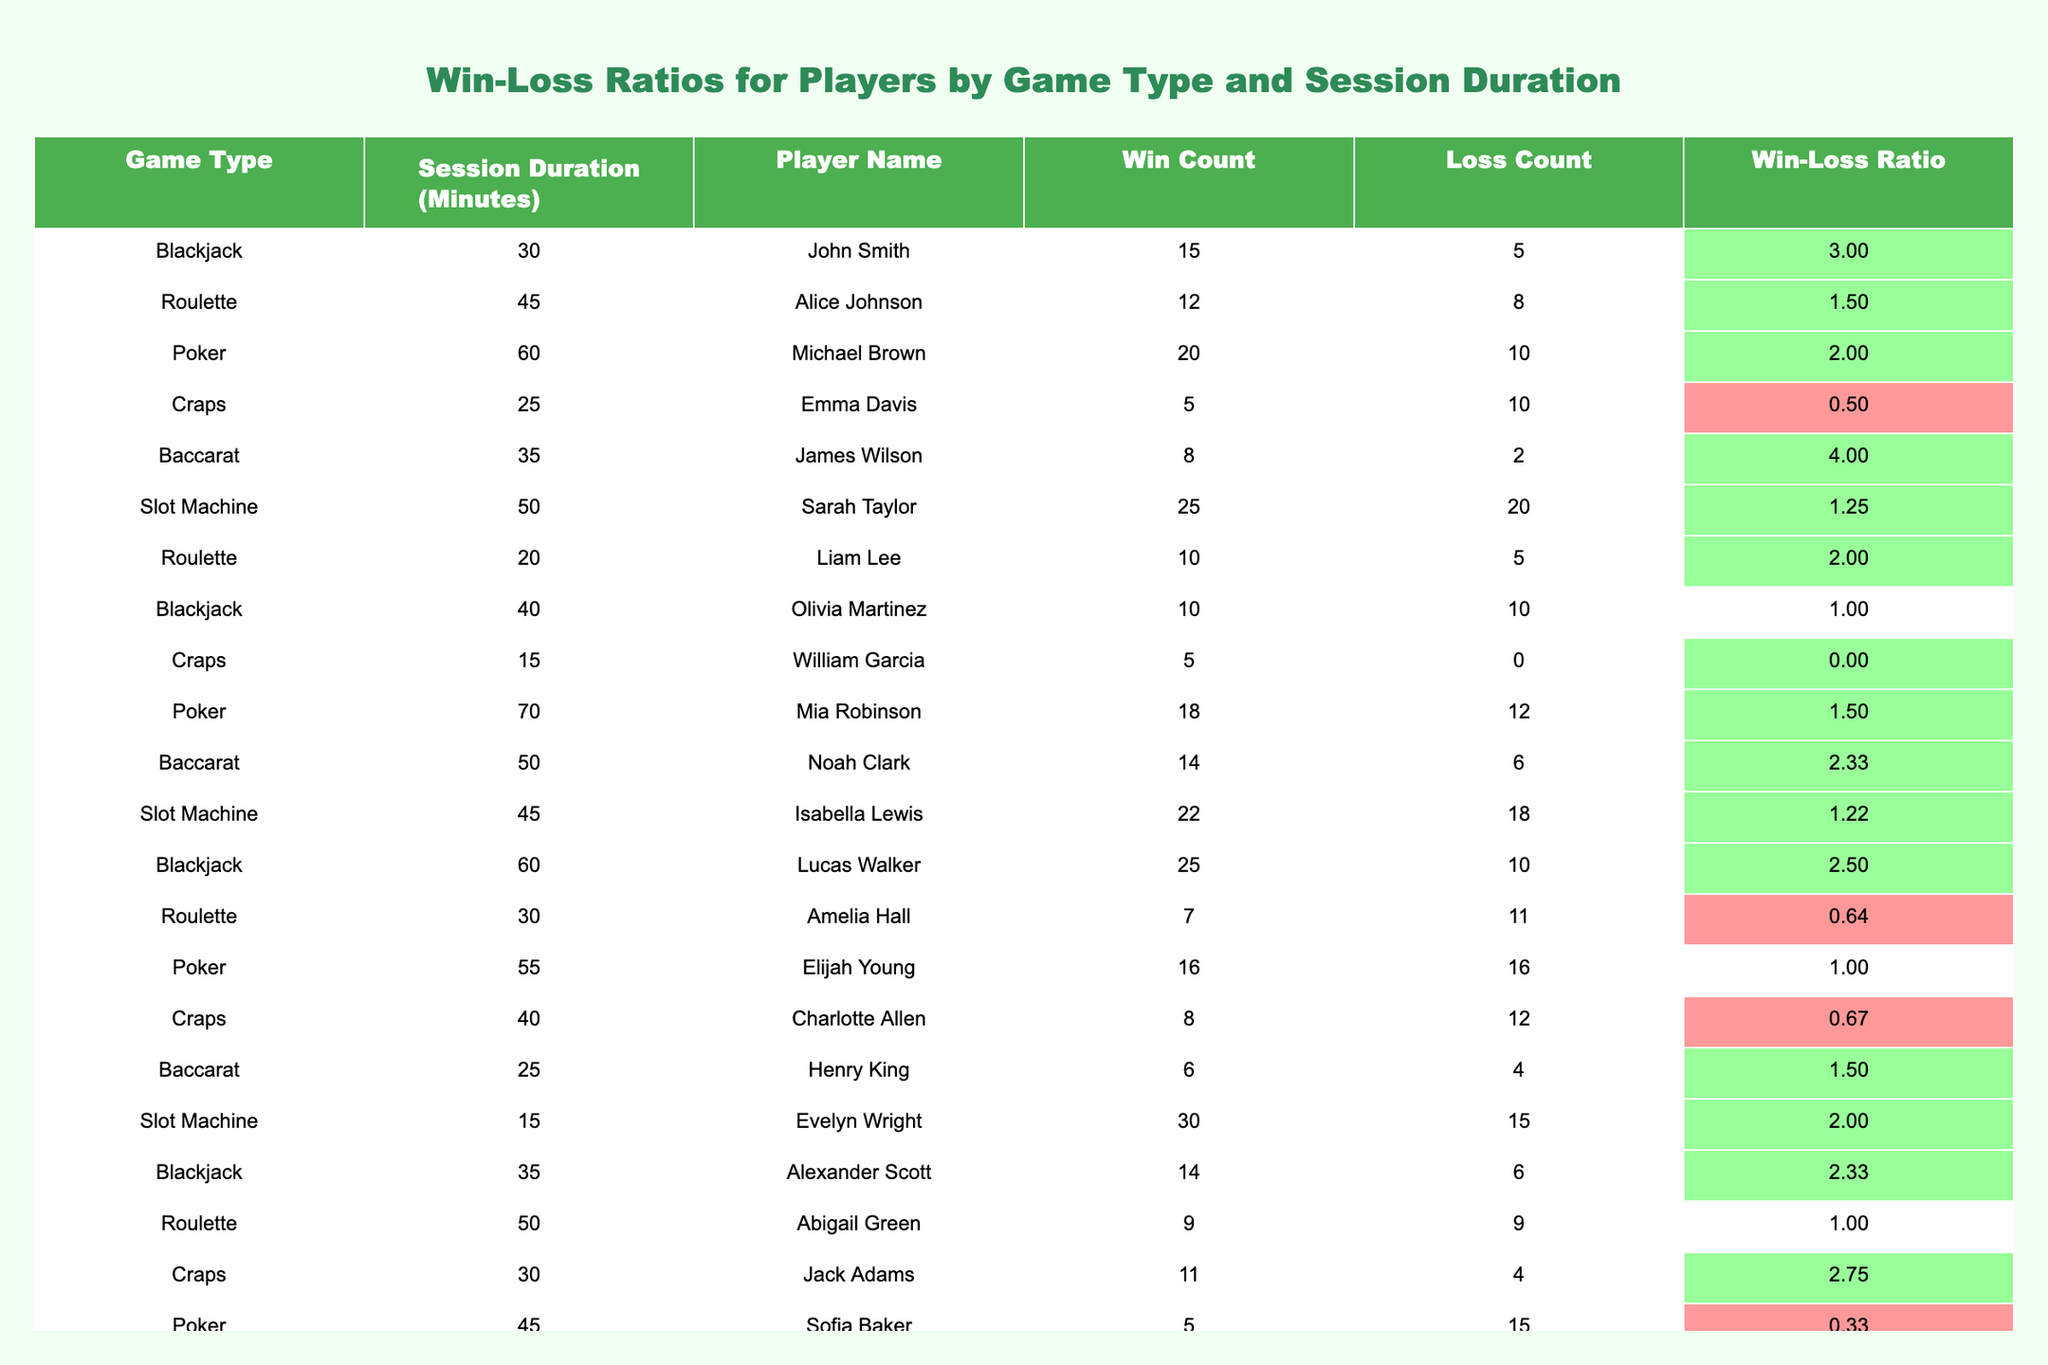What is the highest Win-Loss Ratio in the table? By scanning through the "Win-Loss Ratio" column, we can identify the maximum value. The highest ratio is 4.00, which is from James Wilson in Baccarat.
Answer: 4.00 Which game type has the lowest average Win-Loss Ratio? We calculate the average Win-Loss Ratio for each game type by summing the ratios and dividing by the number of occurrences for each game type. The average for Craps is approximately 0.55, which is the lowest of all game types.
Answer: Craps Is there any player with a Win Count of 30 or more? Looking at the "Win Count" column, we see that the player Evelyn Wright has a Win Count of 30, thus there is a player who meets this criterion.
Answer: Yes Which player has the best performance in terms of Win-Loss Ratio when playing Blackjack? We examine the Blackjack entries: John Smith has a ratio of 3.00, Olivia Martinez has 1.00, Lucas Walker has 2.50, and Alexander Scott has 2.33. The highest ratio among these is 3.00 from John Smith.
Answer: John Smith What is the total number of Wins for all players combined? To find this, we sum up all the values in the "Win Count" column. The total comes out to be 304 when calculated.
Answer: 304 Which game type has more players with a ratio greater than 1? We count the occurrences of each game type with a Win-Loss Ratio exceeding 1. Looking at this, Blackjack has 3 players, Roulette has 3, Poker has 2, Craps has 1, Baccarat has 3, and Slot Machine has 1. Therefore, Blackjack, Roulette, and Baccarat have the same number, but they all have players exceeding 1.
Answer: Blackjack, Roulette, Baccarat Who had a perfect score (no losses) and what game did they play? By checking the "Loss Count" column, we find William Garcia with 0 losses in Craps.
Answer: William Garcia, Craps What is the difference between the highest and lowest Win-Loss Ratios in Poker? The highest Win-Loss Ratio in Poker is 2.00 from Michael Brown, while the lowest is 0.33 from Sofia Baker. The difference is calculated as 2.00 - 0.33 = 1.67.
Answer: 1.67 Which player had a Win Count of 25 and what was their Win-Loss Ratio? Scanning the "Win Count," we find Sarah Taylor with a count of 25, and her corresponding Win-Loss Ratio is 1.25.
Answer: Sarah Taylor, 1.25 How many players played for a session duration of 60 minutes or more? We look for players in the "Session Duration" column who have 60 minutes or longer. The players listed are Michael Brown, Mia Robinson, and Lucas Walker. Thus, there are 3 players.
Answer: 3 What is the average Win-Loss Ratio for all players who played Roulette? Summing the Win-Loss Ratios for all Roulette players (1.50, 2.00, 0.64, 1.00) gives us 5.14, and dividing by the number of players (4) yields an average of 1.285.
Answer: 1.29 